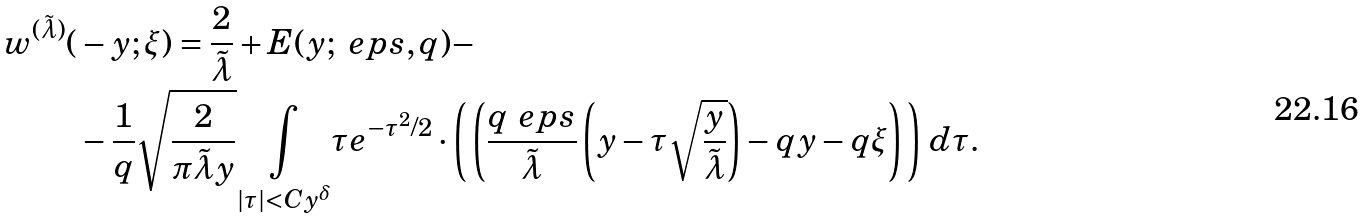<formula> <loc_0><loc_0><loc_500><loc_500>w ^ { ( \tilde { \lambda } ) } ( & - y ; \xi ) = \frac { 2 } { \tilde { \lambda } } + E ( y ; \ e p s , q ) - \\ & - \frac { 1 } { q } \sqrt { \frac { 2 } { \pi \tilde { \lambda } y } } { \underset { | \tau | < C y ^ { \delta } } { \int } } \tau e ^ { - \tau ^ { 2 } / 2 } \cdot \left ( \, \left ( \frac { q \ e p s } { \tilde { \lambda } } \left ( y - \tau \sqrt { \frac { y } { \tilde { \lambda } } } \right ) - q y - q \xi \right ) \, \right ) \, d \tau .</formula> 